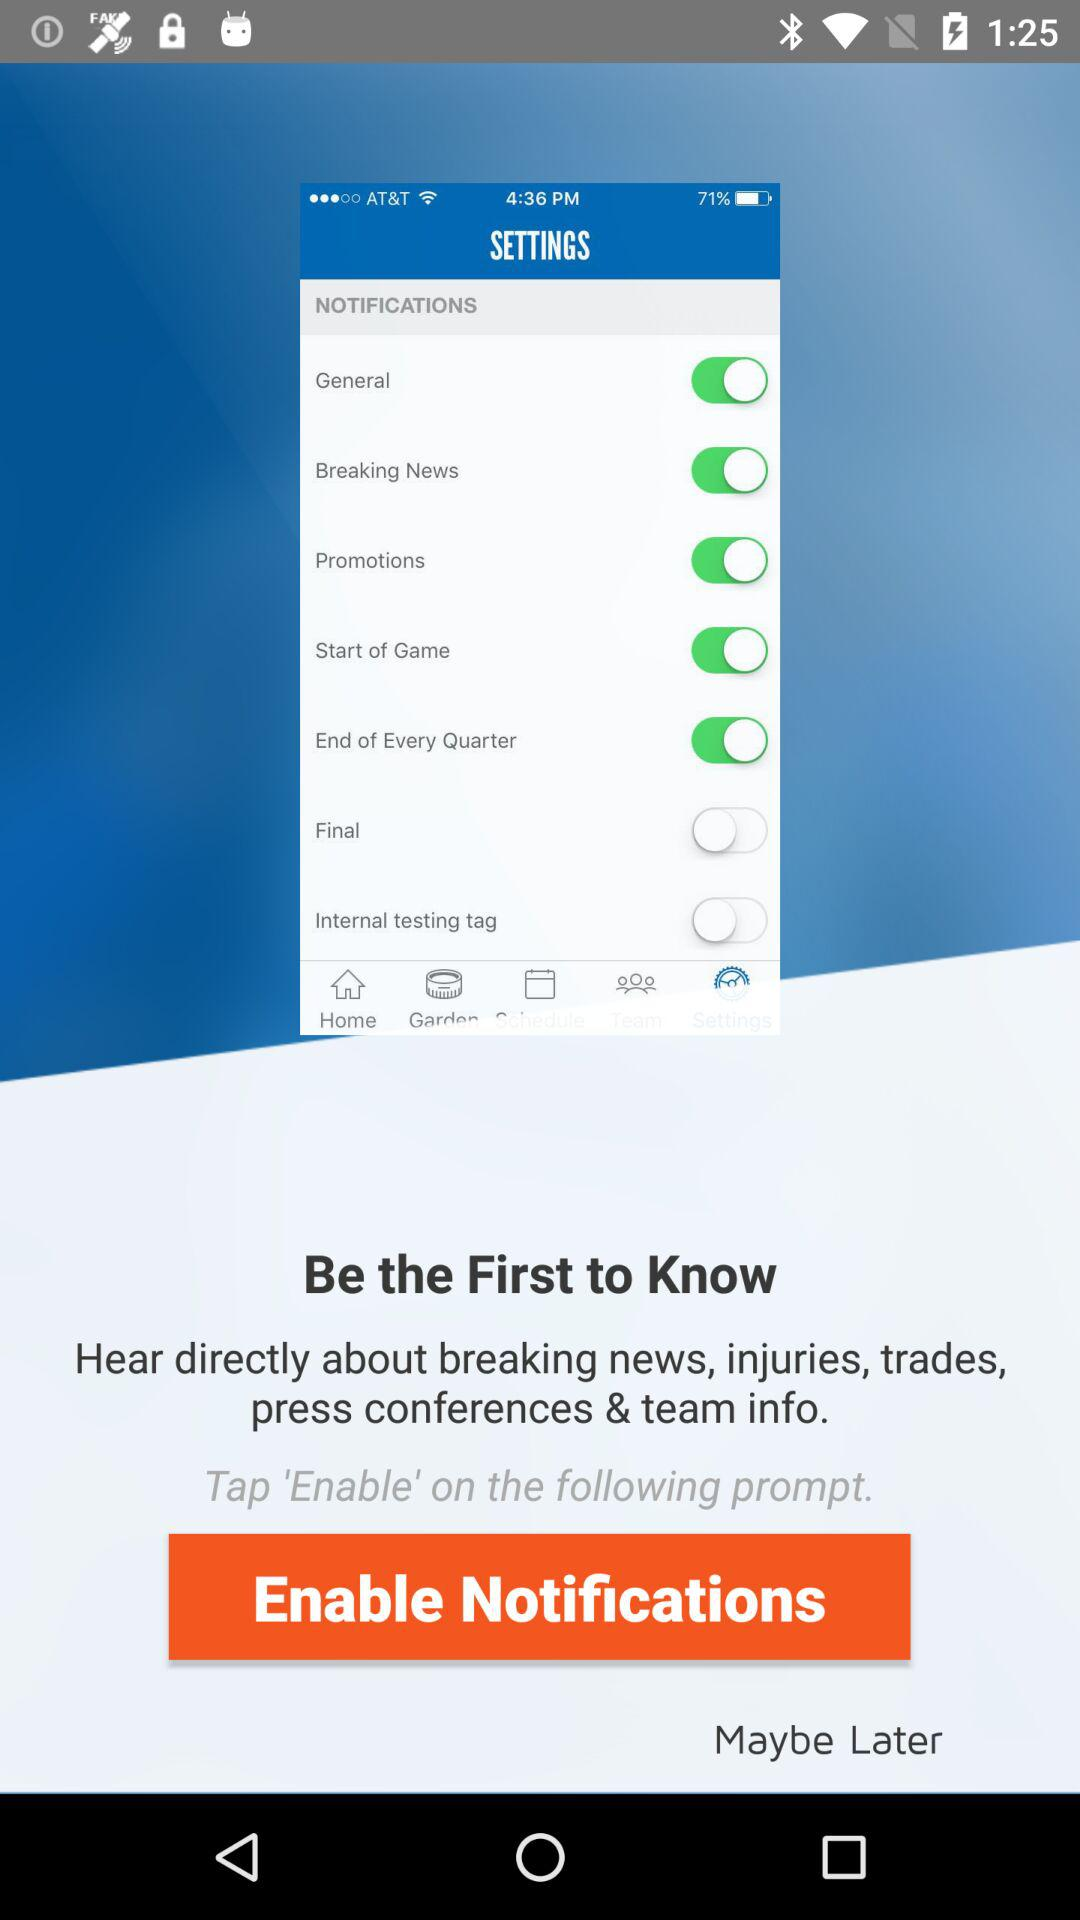What notifications are disabled? The notifications disabled are "Final" and "Internal testing tag". 